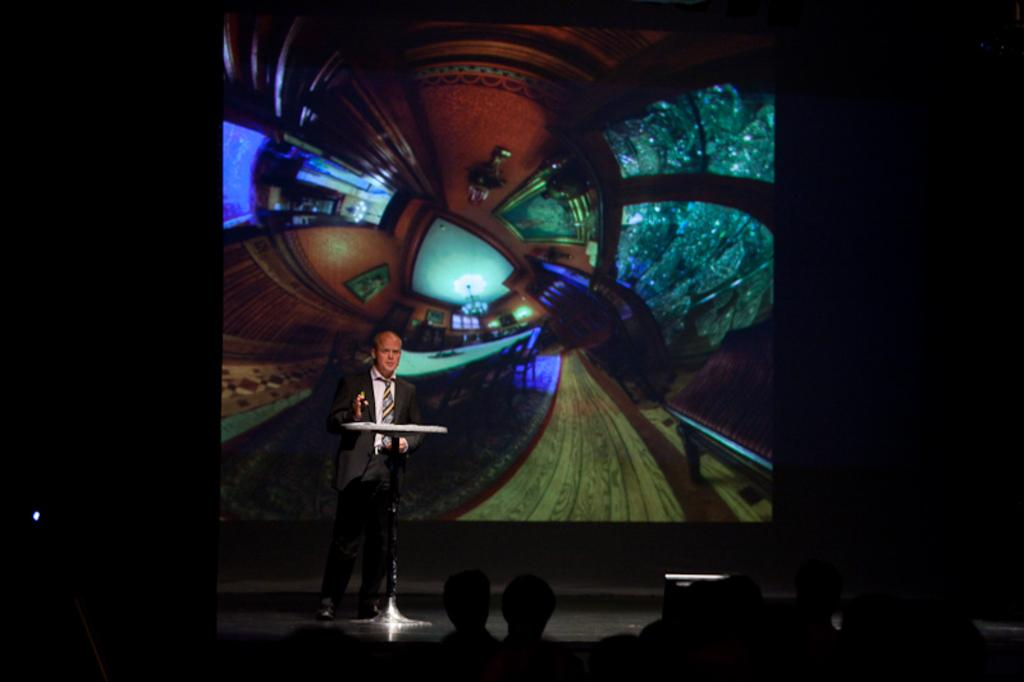What is the main subject of the image? The main subject of the image is a group of people. Can you describe the man in the image? There is a man standing near a podium in the image. What can be seen in the background of the image? There is a screen in the background of the image. What type of wood is being used to build the laugh in the image? There is no laugh or wood present in the image. 